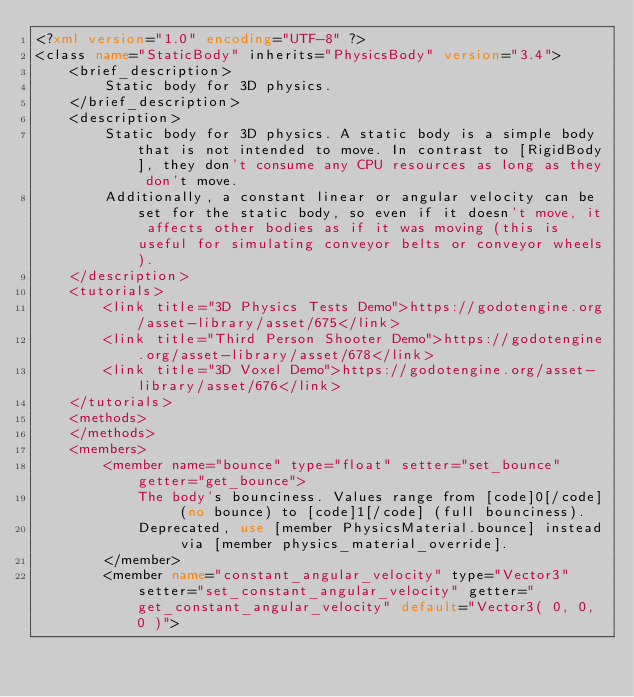Convert code to text. <code><loc_0><loc_0><loc_500><loc_500><_XML_><?xml version="1.0" encoding="UTF-8" ?>
<class name="StaticBody" inherits="PhysicsBody" version="3.4">
	<brief_description>
		Static body for 3D physics.
	</brief_description>
	<description>
		Static body for 3D physics. A static body is a simple body that is not intended to move. In contrast to [RigidBody], they don't consume any CPU resources as long as they don't move.
		Additionally, a constant linear or angular velocity can be set for the static body, so even if it doesn't move, it affects other bodies as if it was moving (this is useful for simulating conveyor belts or conveyor wheels).
	</description>
	<tutorials>
		<link title="3D Physics Tests Demo">https://godotengine.org/asset-library/asset/675</link>
		<link title="Third Person Shooter Demo">https://godotengine.org/asset-library/asset/678</link>
		<link title="3D Voxel Demo">https://godotengine.org/asset-library/asset/676</link>
	</tutorials>
	<methods>
	</methods>
	<members>
		<member name="bounce" type="float" setter="set_bounce" getter="get_bounce">
			The body's bounciness. Values range from [code]0[/code] (no bounce) to [code]1[/code] (full bounciness).
			Deprecated, use [member PhysicsMaterial.bounce] instead via [member physics_material_override].
		</member>
		<member name="constant_angular_velocity" type="Vector3" setter="set_constant_angular_velocity" getter="get_constant_angular_velocity" default="Vector3( 0, 0, 0 )"></code> 